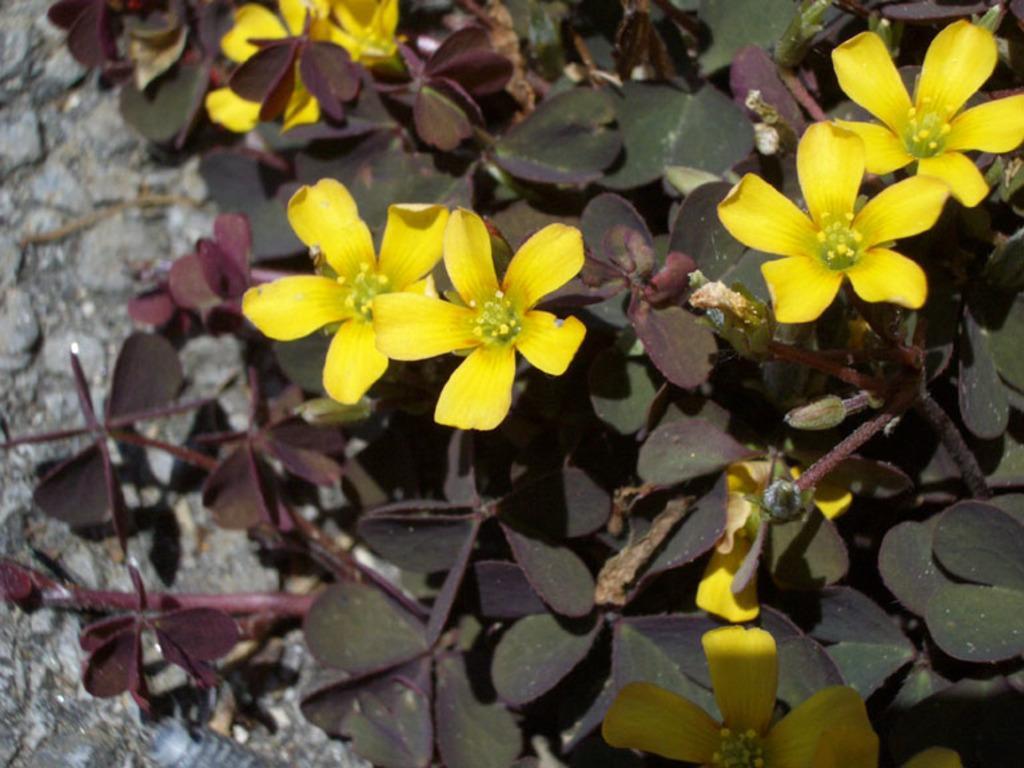In one or two sentences, can you explain what this image depicts? In this image in the foreground there are some plants and flowers, and in the background there is a wall. 